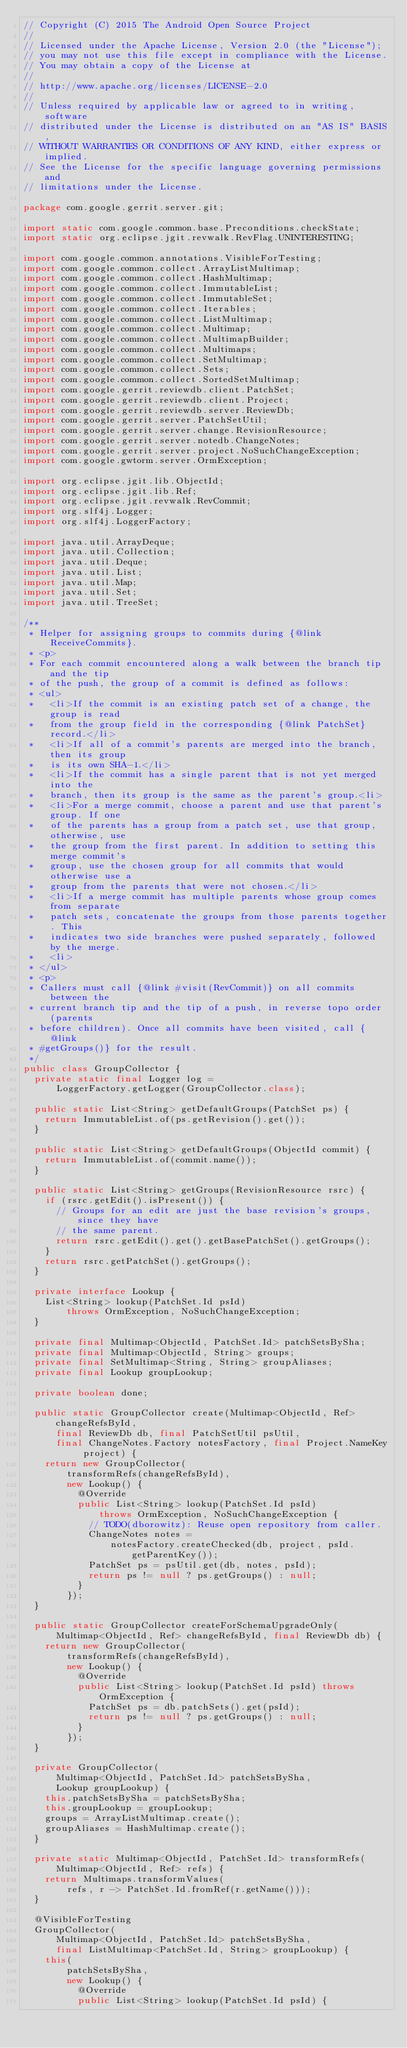Convert code to text. <code><loc_0><loc_0><loc_500><loc_500><_Java_>// Copyright (C) 2015 The Android Open Source Project
//
// Licensed under the Apache License, Version 2.0 (the "License");
// you may not use this file except in compliance with the License.
// You may obtain a copy of the License at
//
// http://www.apache.org/licenses/LICENSE-2.0
//
// Unless required by applicable law or agreed to in writing, software
// distributed under the License is distributed on an "AS IS" BASIS,
// WITHOUT WARRANTIES OR CONDITIONS OF ANY KIND, either express or implied.
// See the License for the specific language governing permissions and
// limitations under the License.

package com.google.gerrit.server.git;

import static com.google.common.base.Preconditions.checkState;
import static org.eclipse.jgit.revwalk.RevFlag.UNINTERESTING;

import com.google.common.annotations.VisibleForTesting;
import com.google.common.collect.ArrayListMultimap;
import com.google.common.collect.HashMultimap;
import com.google.common.collect.ImmutableList;
import com.google.common.collect.ImmutableSet;
import com.google.common.collect.Iterables;
import com.google.common.collect.ListMultimap;
import com.google.common.collect.Multimap;
import com.google.common.collect.MultimapBuilder;
import com.google.common.collect.Multimaps;
import com.google.common.collect.SetMultimap;
import com.google.common.collect.Sets;
import com.google.common.collect.SortedSetMultimap;
import com.google.gerrit.reviewdb.client.PatchSet;
import com.google.gerrit.reviewdb.client.Project;
import com.google.gerrit.reviewdb.server.ReviewDb;
import com.google.gerrit.server.PatchSetUtil;
import com.google.gerrit.server.change.RevisionResource;
import com.google.gerrit.server.notedb.ChangeNotes;
import com.google.gerrit.server.project.NoSuchChangeException;
import com.google.gwtorm.server.OrmException;

import org.eclipse.jgit.lib.ObjectId;
import org.eclipse.jgit.lib.Ref;
import org.eclipse.jgit.revwalk.RevCommit;
import org.slf4j.Logger;
import org.slf4j.LoggerFactory;

import java.util.ArrayDeque;
import java.util.Collection;
import java.util.Deque;
import java.util.List;
import java.util.Map;
import java.util.Set;
import java.util.TreeSet;

/**
 * Helper for assigning groups to commits during {@link ReceiveCommits}.
 * <p>
 * For each commit encountered along a walk between the branch tip and the tip
 * of the push, the group of a commit is defined as follows:
 * <ul>
 *   <li>If the commit is an existing patch set of a change, the group is read
 *   from the group field in the corresponding {@link PatchSet} record.</li>
 *   <li>If all of a commit's parents are merged into the branch, then its group
 *   is its own SHA-1.</li>
 *   <li>If the commit has a single parent that is not yet merged into the
 *   branch, then its group is the same as the parent's group.<li>
 *   <li>For a merge commit, choose a parent and use that parent's group. If one
 *   of the parents has a group from a patch set, use that group, otherwise, use
 *   the group from the first parent. In addition to setting this merge commit's
 *   group, use the chosen group for all commits that would otherwise use a
 *   group from the parents that were not chosen.</li>
 *   <li>If a merge commit has multiple parents whose group comes from separate
 *   patch sets, concatenate the groups from those parents together. This
 *   indicates two side branches were pushed separately, followed by the merge.
 *   <li>
 * </ul>
 * <p>
 * Callers must call {@link #visit(RevCommit)} on all commits between the
 * current branch tip and the tip of a push, in reverse topo order (parents
 * before children). Once all commits have been visited, call {@link
 * #getGroups()} for the result.
 */
public class GroupCollector {
  private static final Logger log =
      LoggerFactory.getLogger(GroupCollector.class);

  public static List<String> getDefaultGroups(PatchSet ps) {
    return ImmutableList.of(ps.getRevision().get());
  }

  public static List<String> getDefaultGroups(ObjectId commit) {
    return ImmutableList.of(commit.name());
  }

  public static List<String> getGroups(RevisionResource rsrc) {
    if (rsrc.getEdit().isPresent()) {
      // Groups for an edit are just the base revision's groups, since they have
      // the same parent.
      return rsrc.getEdit().get().getBasePatchSet().getGroups();
    }
    return rsrc.getPatchSet().getGroups();
  }

  private interface Lookup {
    List<String> lookup(PatchSet.Id psId)
        throws OrmException, NoSuchChangeException;
  }

  private final Multimap<ObjectId, PatchSet.Id> patchSetsBySha;
  private final Multimap<ObjectId, String> groups;
  private final SetMultimap<String, String> groupAliases;
  private final Lookup groupLookup;

  private boolean done;

  public static GroupCollector create(Multimap<ObjectId, Ref> changeRefsById,
      final ReviewDb db, final PatchSetUtil psUtil,
      final ChangeNotes.Factory notesFactory, final Project.NameKey project) {
    return new GroupCollector(
        transformRefs(changeRefsById),
        new Lookup() {
          @Override
          public List<String> lookup(PatchSet.Id psId)
              throws OrmException, NoSuchChangeException {
            // TODO(dborowitz): Reuse open repository from caller.
            ChangeNotes notes =
                notesFactory.createChecked(db, project, psId.getParentKey());
            PatchSet ps = psUtil.get(db, notes, psId);
            return ps != null ? ps.getGroups() : null;
          }
        });
  }

  public static GroupCollector createForSchemaUpgradeOnly(
      Multimap<ObjectId, Ref> changeRefsById, final ReviewDb db) {
    return new GroupCollector(
        transformRefs(changeRefsById),
        new Lookup() {
          @Override
          public List<String> lookup(PatchSet.Id psId) throws OrmException {
            PatchSet ps = db.patchSets().get(psId);
            return ps != null ? ps.getGroups() : null;
          }
        });
  }

  private GroupCollector(
      Multimap<ObjectId, PatchSet.Id> patchSetsBySha,
      Lookup groupLookup) {
    this.patchSetsBySha = patchSetsBySha;
    this.groupLookup = groupLookup;
    groups = ArrayListMultimap.create();
    groupAliases = HashMultimap.create();
  }

  private static Multimap<ObjectId, PatchSet.Id> transformRefs(
      Multimap<ObjectId, Ref> refs) {
    return Multimaps.transformValues(
        refs, r -> PatchSet.Id.fromRef(r.getName()));
  }

  @VisibleForTesting
  GroupCollector(
      Multimap<ObjectId, PatchSet.Id> patchSetsBySha,
      final ListMultimap<PatchSet.Id, String> groupLookup) {
    this(
        patchSetsBySha,
        new Lookup() {
          @Override
          public List<String> lookup(PatchSet.Id psId) {</code> 